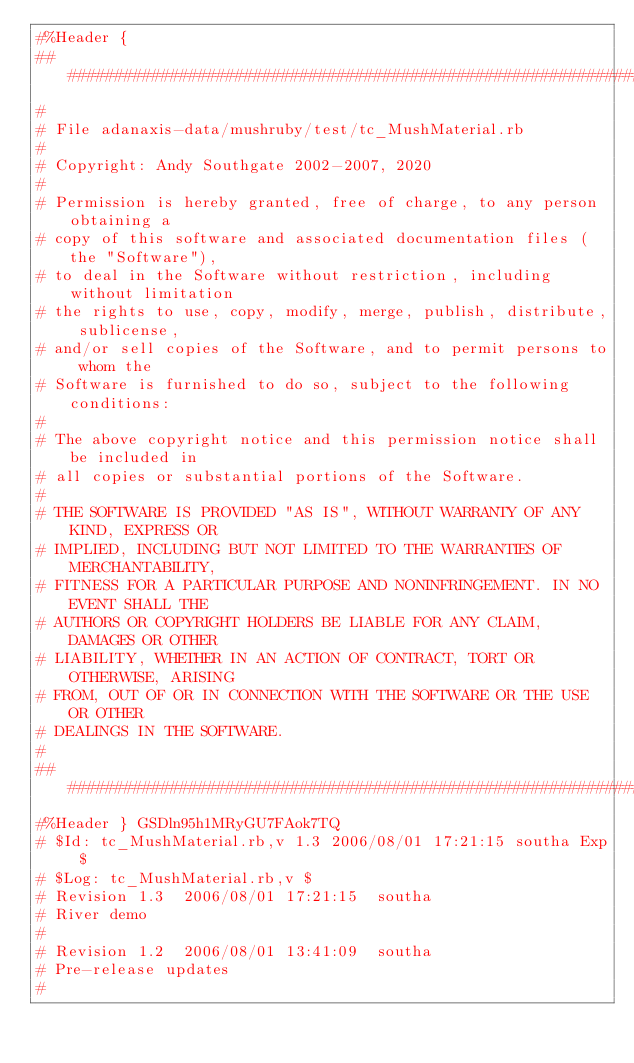<code> <loc_0><loc_0><loc_500><loc_500><_Ruby_>#%Header {
##############################################################################
#
# File adanaxis-data/mushruby/test/tc_MushMaterial.rb
#
# Copyright: Andy Southgate 2002-2007, 2020
#
# Permission is hereby granted, free of charge, to any person obtaining a
# copy of this software and associated documentation files (the "Software"),
# to deal in the Software without restriction, including without limitation
# the rights to use, copy, modify, merge, publish, distribute, sublicense,
# and/or sell copies of the Software, and to permit persons to whom the
# Software is furnished to do so, subject to the following conditions:
#
# The above copyright notice and this permission notice shall be included in
# all copies or substantial portions of the Software.
#
# THE SOFTWARE IS PROVIDED "AS IS", WITHOUT WARRANTY OF ANY KIND, EXPRESS OR
# IMPLIED, INCLUDING BUT NOT LIMITED TO THE WARRANTIES OF MERCHANTABILITY,
# FITNESS FOR A PARTICULAR PURPOSE AND NONINFRINGEMENT. IN NO EVENT SHALL THE
# AUTHORS OR COPYRIGHT HOLDERS BE LIABLE FOR ANY CLAIM, DAMAGES OR OTHER
# LIABILITY, WHETHER IN AN ACTION OF CONTRACT, TORT OR OTHERWISE, ARISING
# FROM, OUT OF OR IN CONNECTION WITH THE SOFTWARE OR THE USE OR OTHER
# DEALINGS IN THE SOFTWARE.
#
##############################################################################
#%Header } GSDln95h1MRyGU7FAok7TQ
# $Id: tc_MushMaterial.rb,v 1.3 2006/08/01 17:21:15 southa Exp $
# $Log: tc_MushMaterial.rb,v $
# Revision 1.3  2006/08/01 17:21:15  southa
# River demo
#
# Revision 1.2  2006/08/01 13:41:09  southa
# Pre-release updates
#
</code> 